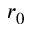Convert formula to latex. <formula><loc_0><loc_0><loc_500><loc_500>r _ { 0 }</formula> 